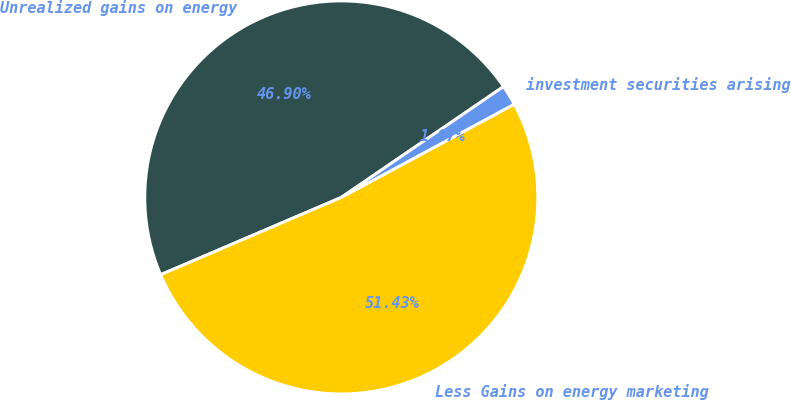<chart> <loc_0><loc_0><loc_500><loc_500><pie_chart><fcel>Unrealized gains on energy<fcel>Less Gains on energy marketing<fcel>investment securities arising<nl><fcel>46.9%<fcel>51.44%<fcel>1.67%<nl></chart> 